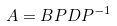Convert formula to latex. <formula><loc_0><loc_0><loc_500><loc_500>A = B P D P ^ { - 1 }</formula> 